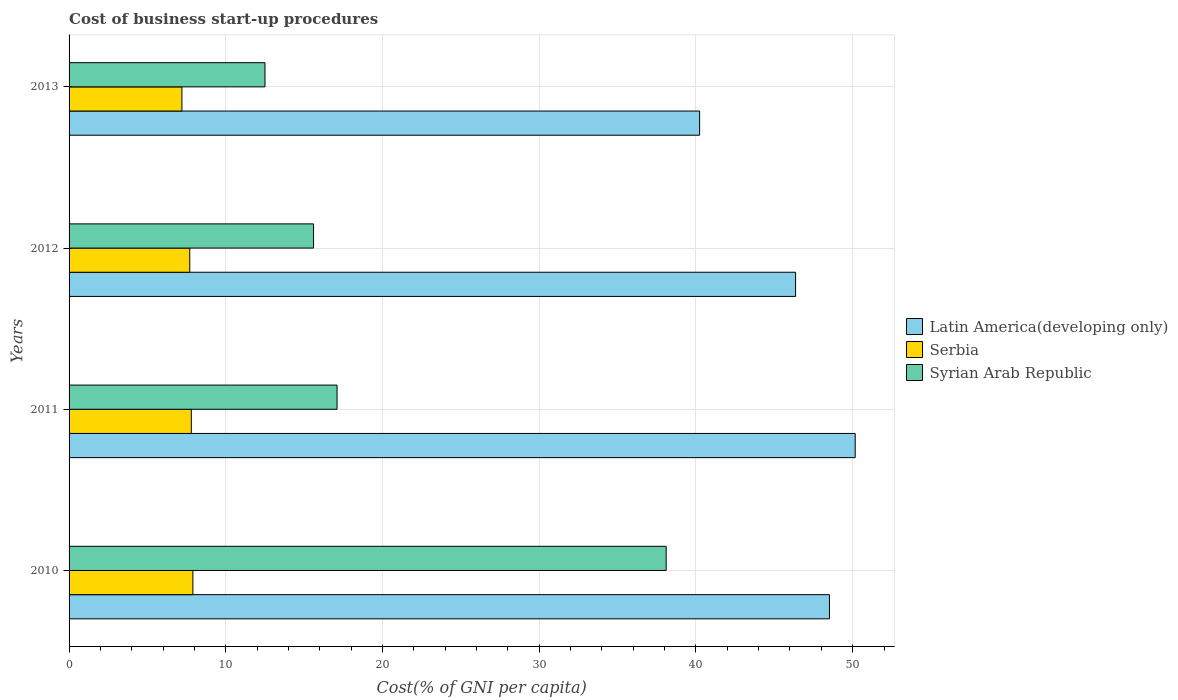Are the number of bars per tick equal to the number of legend labels?
Provide a succinct answer. Yes. How many bars are there on the 1st tick from the top?
Keep it short and to the point. 3. What is the label of the 3rd group of bars from the top?
Your answer should be compact. 2011. What is the cost of business start-up procedures in Syrian Arab Republic in 2012?
Give a very brief answer. 15.6. What is the total cost of business start-up procedures in Serbia in the graph?
Your answer should be very brief. 30.6. What is the difference between the cost of business start-up procedures in Latin America(developing only) in 2012 and that in 2013?
Provide a short and direct response. 6.12. What is the difference between the cost of business start-up procedures in Serbia in 2010 and the cost of business start-up procedures in Latin America(developing only) in 2012?
Offer a terse response. -38.46. What is the average cost of business start-up procedures in Syrian Arab Republic per year?
Your answer should be compact. 20.82. In the year 2010, what is the difference between the cost of business start-up procedures in Syrian Arab Republic and cost of business start-up procedures in Serbia?
Your response must be concise. 30.2. In how many years, is the cost of business start-up procedures in Serbia greater than 30 %?
Your answer should be compact. 0. What is the ratio of the cost of business start-up procedures in Serbia in 2010 to that in 2012?
Provide a succinct answer. 1.03. Is the cost of business start-up procedures in Syrian Arab Republic in 2010 less than that in 2013?
Provide a succinct answer. No. Is the difference between the cost of business start-up procedures in Syrian Arab Republic in 2010 and 2013 greater than the difference between the cost of business start-up procedures in Serbia in 2010 and 2013?
Your answer should be compact. Yes. What is the difference between the highest and the second highest cost of business start-up procedures in Latin America(developing only)?
Your response must be concise. 1.64. What is the difference between the highest and the lowest cost of business start-up procedures in Serbia?
Your answer should be very brief. 0.7. What does the 1st bar from the top in 2013 represents?
Keep it short and to the point. Syrian Arab Republic. What does the 1st bar from the bottom in 2011 represents?
Keep it short and to the point. Latin America(developing only). Is it the case that in every year, the sum of the cost of business start-up procedures in Latin America(developing only) and cost of business start-up procedures in Syrian Arab Republic is greater than the cost of business start-up procedures in Serbia?
Keep it short and to the point. Yes. How many bars are there?
Provide a short and direct response. 12. Are all the bars in the graph horizontal?
Make the answer very short. Yes. How many years are there in the graph?
Ensure brevity in your answer.  4. What is the difference between two consecutive major ticks on the X-axis?
Ensure brevity in your answer.  10. Are the values on the major ticks of X-axis written in scientific E-notation?
Your response must be concise. No. Where does the legend appear in the graph?
Give a very brief answer. Center right. How many legend labels are there?
Offer a terse response. 3. What is the title of the graph?
Offer a very short reply. Cost of business start-up procedures. What is the label or title of the X-axis?
Offer a terse response. Cost(% of GNI per capita). What is the Cost(% of GNI per capita) of Latin America(developing only) in 2010?
Provide a short and direct response. 48.52. What is the Cost(% of GNI per capita) of Syrian Arab Republic in 2010?
Your answer should be very brief. 38.1. What is the Cost(% of GNI per capita) in Latin America(developing only) in 2011?
Your answer should be compact. 50.16. What is the Cost(% of GNI per capita) in Serbia in 2011?
Your answer should be compact. 7.8. What is the Cost(% of GNI per capita) of Syrian Arab Republic in 2011?
Make the answer very short. 17.1. What is the Cost(% of GNI per capita) of Latin America(developing only) in 2012?
Offer a very short reply. 46.36. What is the Cost(% of GNI per capita) of Serbia in 2012?
Provide a short and direct response. 7.7. What is the Cost(% of GNI per capita) in Latin America(developing only) in 2013?
Keep it short and to the point. 40.23. What is the Cost(% of GNI per capita) of Serbia in 2013?
Give a very brief answer. 7.2. Across all years, what is the maximum Cost(% of GNI per capita) in Latin America(developing only)?
Keep it short and to the point. 50.16. Across all years, what is the maximum Cost(% of GNI per capita) of Serbia?
Offer a terse response. 7.9. Across all years, what is the maximum Cost(% of GNI per capita) of Syrian Arab Republic?
Keep it short and to the point. 38.1. Across all years, what is the minimum Cost(% of GNI per capita) in Latin America(developing only)?
Offer a very short reply. 40.23. What is the total Cost(% of GNI per capita) in Latin America(developing only) in the graph?
Make the answer very short. 185.27. What is the total Cost(% of GNI per capita) of Serbia in the graph?
Your response must be concise. 30.6. What is the total Cost(% of GNI per capita) of Syrian Arab Republic in the graph?
Give a very brief answer. 83.3. What is the difference between the Cost(% of GNI per capita) of Latin America(developing only) in 2010 and that in 2011?
Provide a succinct answer. -1.64. What is the difference between the Cost(% of GNI per capita) in Serbia in 2010 and that in 2011?
Give a very brief answer. 0.1. What is the difference between the Cost(% of GNI per capita) in Syrian Arab Republic in 2010 and that in 2011?
Your answer should be compact. 21. What is the difference between the Cost(% of GNI per capita) in Latin America(developing only) in 2010 and that in 2012?
Give a very brief answer. 2.16. What is the difference between the Cost(% of GNI per capita) of Latin America(developing only) in 2010 and that in 2013?
Give a very brief answer. 8.28. What is the difference between the Cost(% of GNI per capita) in Syrian Arab Republic in 2010 and that in 2013?
Provide a succinct answer. 25.6. What is the difference between the Cost(% of GNI per capita) in Latin America(developing only) in 2011 and that in 2012?
Offer a terse response. 3.8. What is the difference between the Cost(% of GNI per capita) of Serbia in 2011 and that in 2012?
Provide a short and direct response. 0.1. What is the difference between the Cost(% of GNI per capita) of Syrian Arab Republic in 2011 and that in 2012?
Provide a succinct answer. 1.5. What is the difference between the Cost(% of GNI per capita) of Latin America(developing only) in 2011 and that in 2013?
Your response must be concise. 9.93. What is the difference between the Cost(% of GNI per capita) in Syrian Arab Republic in 2011 and that in 2013?
Give a very brief answer. 4.6. What is the difference between the Cost(% of GNI per capita) in Latin America(developing only) in 2012 and that in 2013?
Your answer should be very brief. 6.12. What is the difference between the Cost(% of GNI per capita) of Latin America(developing only) in 2010 and the Cost(% of GNI per capita) of Serbia in 2011?
Keep it short and to the point. 40.72. What is the difference between the Cost(% of GNI per capita) of Latin America(developing only) in 2010 and the Cost(% of GNI per capita) of Syrian Arab Republic in 2011?
Give a very brief answer. 31.42. What is the difference between the Cost(% of GNI per capita) of Latin America(developing only) in 2010 and the Cost(% of GNI per capita) of Serbia in 2012?
Your answer should be very brief. 40.82. What is the difference between the Cost(% of GNI per capita) of Latin America(developing only) in 2010 and the Cost(% of GNI per capita) of Syrian Arab Republic in 2012?
Provide a succinct answer. 32.92. What is the difference between the Cost(% of GNI per capita) of Latin America(developing only) in 2010 and the Cost(% of GNI per capita) of Serbia in 2013?
Provide a short and direct response. 41.32. What is the difference between the Cost(% of GNI per capita) in Latin America(developing only) in 2010 and the Cost(% of GNI per capita) in Syrian Arab Republic in 2013?
Offer a very short reply. 36.02. What is the difference between the Cost(% of GNI per capita) of Latin America(developing only) in 2011 and the Cost(% of GNI per capita) of Serbia in 2012?
Provide a succinct answer. 42.46. What is the difference between the Cost(% of GNI per capita) in Latin America(developing only) in 2011 and the Cost(% of GNI per capita) in Syrian Arab Republic in 2012?
Make the answer very short. 34.56. What is the difference between the Cost(% of GNI per capita) of Latin America(developing only) in 2011 and the Cost(% of GNI per capita) of Serbia in 2013?
Provide a succinct answer. 42.96. What is the difference between the Cost(% of GNI per capita) of Latin America(developing only) in 2011 and the Cost(% of GNI per capita) of Syrian Arab Republic in 2013?
Provide a succinct answer. 37.66. What is the difference between the Cost(% of GNI per capita) in Latin America(developing only) in 2012 and the Cost(% of GNI per capita) in Serbia in 2013?
Provide a succinct answer. 39.16. What is the difference between the Cost(% of GNI per capita) in Latin America(developing only) in 2012 and the Cost(% of GNI per capita) in Syrian Arab Republic in 2013?
Make the answer very short. 33.86. What is the difference between the Cost(% of GNI per capita) in Serbia in 2012 and the Cost(% of GNI per capita) in Syrian Arab Republic in 2013?
Make the answer very short. -4.8. What is the average Cost(% of GNI per capita) of Latin America(developing only) per year?
Offer a terse response. 46.32. What is the average Cost(% of GNI per capita) in Serbia per year?
Your response must be concise. 7.65. What is the average Cost(% of GNI per capita) in Syrian Arab Republic per year?
Your answer should be compact. 20.82. In the year 2010, what is the difference between the Cost(% of GNI per capita) of Latin America(developing only) and Cost(% of GNI per capita) of Serbia?
Ensure brevity in your answer.  40.62. In the year 2010, what is the difference between the Cost(% of GNI per capita) in Latin America(developing only) and Cost(% of GNI per capita) in Syrian Arab Republic?
Provide a succinct answer. 10.42. In the year 2010, what is the difference between the Cost(% of GNI per capita) in Serbia and Cost(% of GNI per capita) in Syrian Arab Republic?
Your response must be concise. -30.2. In the year 2011, what is the difference between the Cost(% of GNI per capita) in Latin America(developing only) and Cost(% of GNI per capita) in Serbia?
Provide a short and direct response. 42.36. In the year 2011, what is the difference between the Cost(% of GNI per capita) in Latin America(developing only) and Cost(% of GNI per capita) in Syrian Arab Republic?
Offer a very short reply. 33.06. In the year 2011, what is the difference between the Cost(% of GNI per capita) of Serbia and Cost(% of GNI per capita) of Syrian Arab Republic?
Your response must be concise. -9.3. In the year 2012, what is the difference between the Cost(% of GNI per capita) in Latin America(developing only) and Cost(% of GNI per capita) in Serbia?
Your answer should be very brief. 38.66. In the year 2012, what is the difference between the Cost(% of GNI per capita) in Latin America(developing only) and Cost(% of GNI per capita) in Syrian Arab Republic?
Give a very brief answer. 30.76. In the year 2012, what is the difference between the Cost(% of GNI per capita) of Serbia and Cost(% of GNI per capita) of Syrian Arab Republic?
Provide a succinct answer. -7.9. In the year 2013, what is the difference between the Cost(% of GNI per capita) of Latin America(developing only) and Cost(% of GNI per capita) of Serbia?
Make the answer very short. 33.03. In the year 2013, what is the difference between the Cost(% of GNI per capita) of Latin America(developing only) and Cost(% of GNI per capita) of Syrian Arab Republic?
Your answer should be very brief. 27.73. What is the ratio of the Cost(% of GNI per capita) in Latin America(developing only) in 2010 to that in 2011?
Your answer should be very brief. 0.97. What is the ratio of the Cost(% of GNI per capita) of Serbia in 2010 to that in 2011?
Provide a short and direct response. 1.01. What is the ratio of the Cost(% of GNI per capita) of Syrian Arab Republic in 2010 to that in 2011?
Keep it short and to the point. 2.23. What is the ratio of the Cost(% of GNI per capita) of Latin America(developing only) in 2010 to that in 2012?
Provide a short and direct response. 1.05. What is the ratio of the Cost(% of GNI per capita) in Syrian Arab Republic in 2010 to that in 2012?
Your answer should be very brief. 2.44. What is the ratio of the Cost(% of GNI per capita) in Latin America(developing only) in 2010 to that in 2013?
Provide a succinct answer. 1.21. What is the ratio of the Cost(% of GNI per capita) of Serbia in 2010 to that in 2013?
Ensure brevity in your answer.  1.1. What is the ratio of the Cost(% of GNI per capita) in Syrian Arab Republic in 2010 to that in 2013?
Ensure brevity in your answer.  3.05. What is the ratio of the Cost(% of GNI per capita) of Latin America(developing only) in 2011 to that in 2012?
Your response must be concise. 1.08. What is the ratio of the Cost(% of GNI per capita) in Syrian Arab Republic in 2011 to that in 2012?
Your answer should be very brief. 1.1. What is the ratio of the Cost(% of GNI per capita) of Latin America(developing only) in 2011 to that in 2013?
Offer a terse response. 1.25. What is the ratio of the Cost(% of GNI per capita) in Syrian Arab Republic in 2011 to that in 2013?
Your answer should be compact. 1.37. What is the ratio of the Cost(% of GNI per capita) of Latin America(developing only) in 2012 to that in 2013?
Your response must be concise. 1.15. What is the ratio of the Cost(% of GNI per capita) in Serbia in 2012 to that in 2013?
Ensure brevity in your answer.  1.07. What is the ratio of the Cost(% of GNI per capita) in Syrian Arab Republic in 2012 to that in 2013?
Your answer should be very brief. 1.25. What is the difference between the highest and the second highest Cost(% of GNI per capita) in Latin America(developing only)?
Your answer should be compact. 1.64. What is the difference between the highest and the second highest Cost(% of GNI per capita) of Serbia?
Offer a terse response. 0.1. What is the difference between the highest and the lowest Cost(% of GNI per capita) in Latin America(developing only)?
Ensure brevity in your answer.  9.93. What is the difference between the highest and the lowest Cost(% of GNI per capita) of Serbia?
Your response must be concise. 0.7. What is the difference between the highest and the lowest Cost(% of GNI per capita) in Syrian Arab Republic?
Provide a short and direct response. 25.6. 